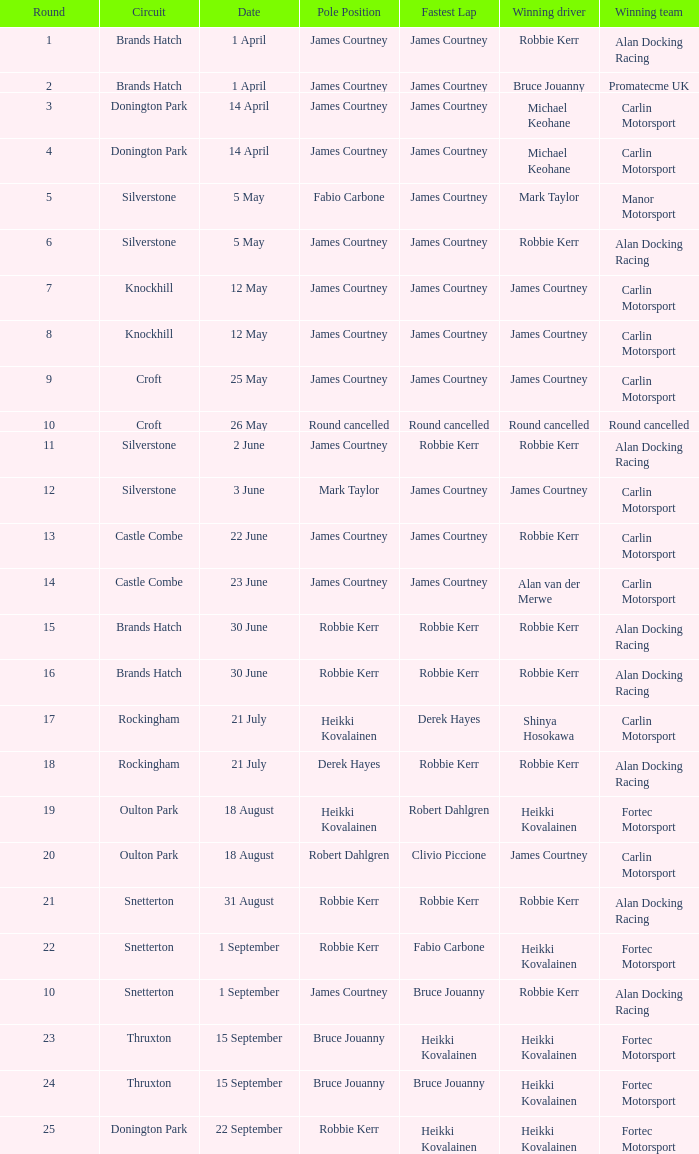What is every date of Mark Taylor as winning driver? 5 May. 